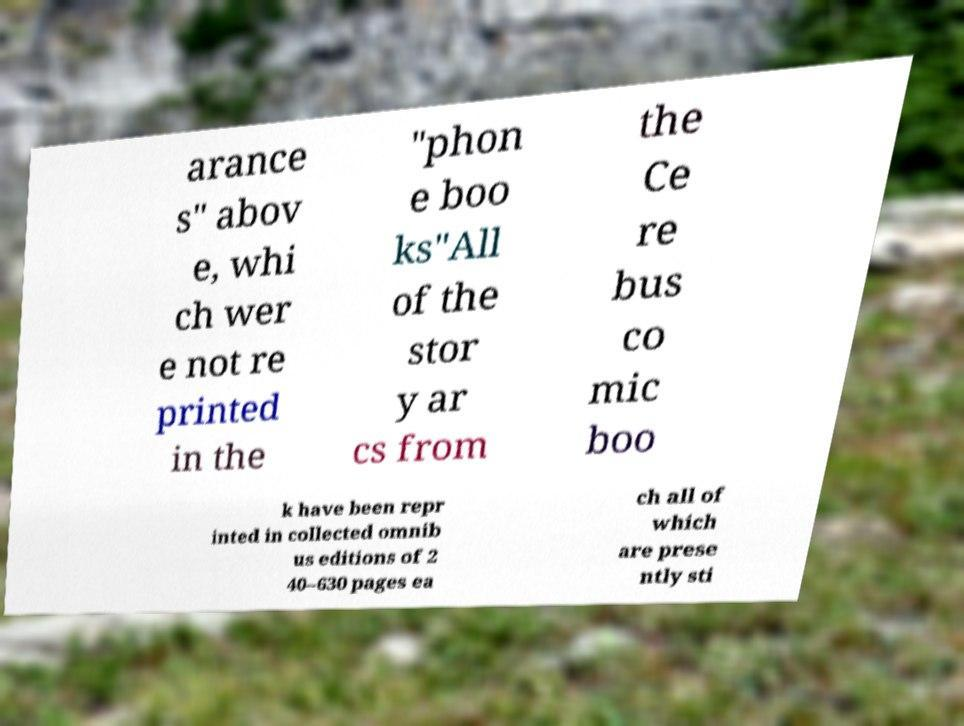Can you read and provide the text displayed in the image?This photo seems to have some interesting text. Can you extract and type it out for me? arance s" abov e, whi ch wer e not re printed in the "phon e boo ks"All of the stor y ar cs from the Ce re bus co mic boo k have been repr inted in collected omnib us editions of 2 40–630 pages ea ch all of which are prese ntly sti 